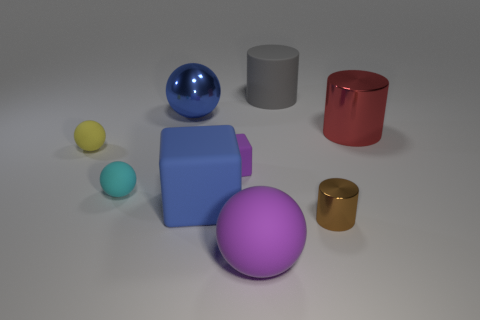Subtract all brown spheres. Subtract all brown cylinders. How many spheres are left? 4 Add 1 tiny yellow rubber balls. How many objects exist? 10 Subtract all cylinders. How many objects are left? 6 Subtract all small cubes. Subtract all tiny red metal cylinders. How many objects are left? 8 Add 2 big blue metallic balls. How many big blue metallic balls are left? 3 Add 9 big purple matte objects. How many big purple matte objects exist? 10 Subtract 0 green spheres. How many objects are left? 9 